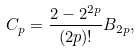<formula> <loc_0><loc_0><loc_500><loc_500>C _ { p } = \frac { 2 - 2 ^ { 2 p } } { ( 2 p ) ! } B _ { 2 p } ,</formula> 